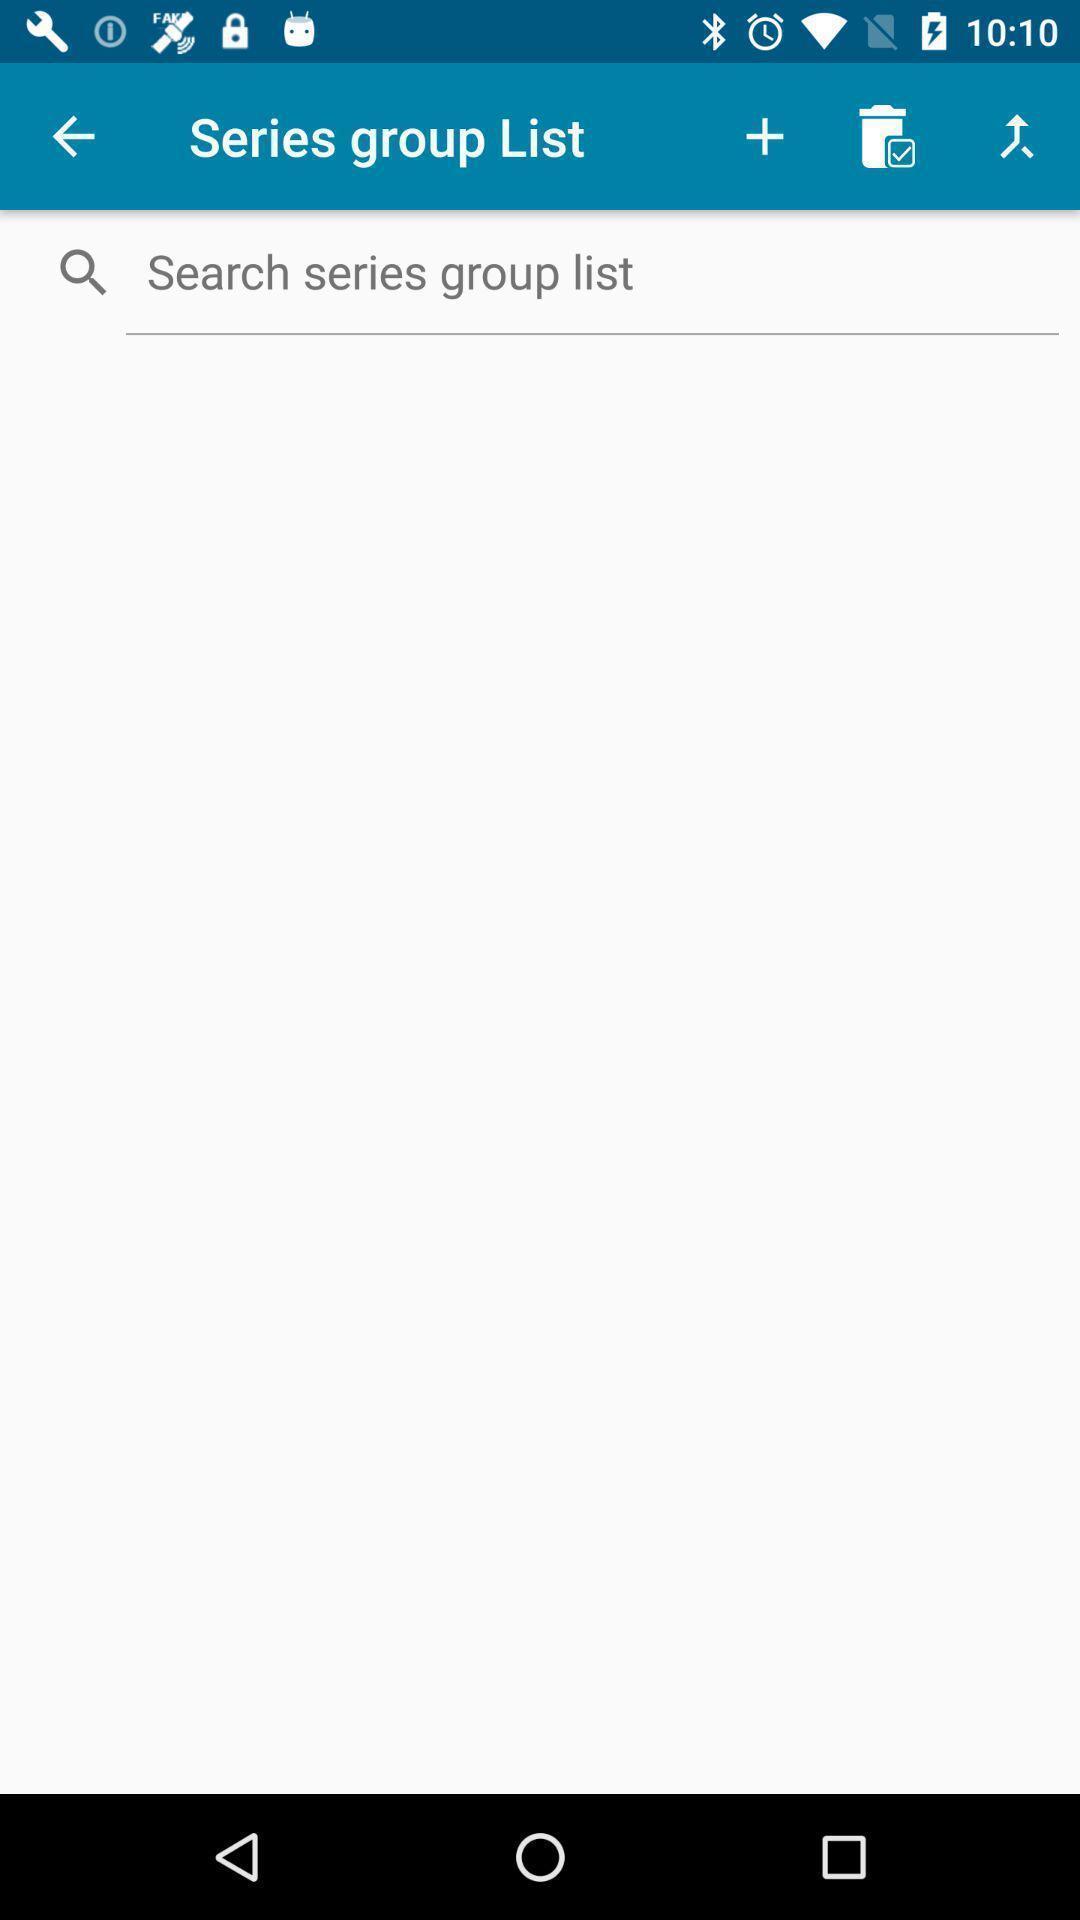Tell me about the visual elements in this screen capture. Search page for a comic collection app. 